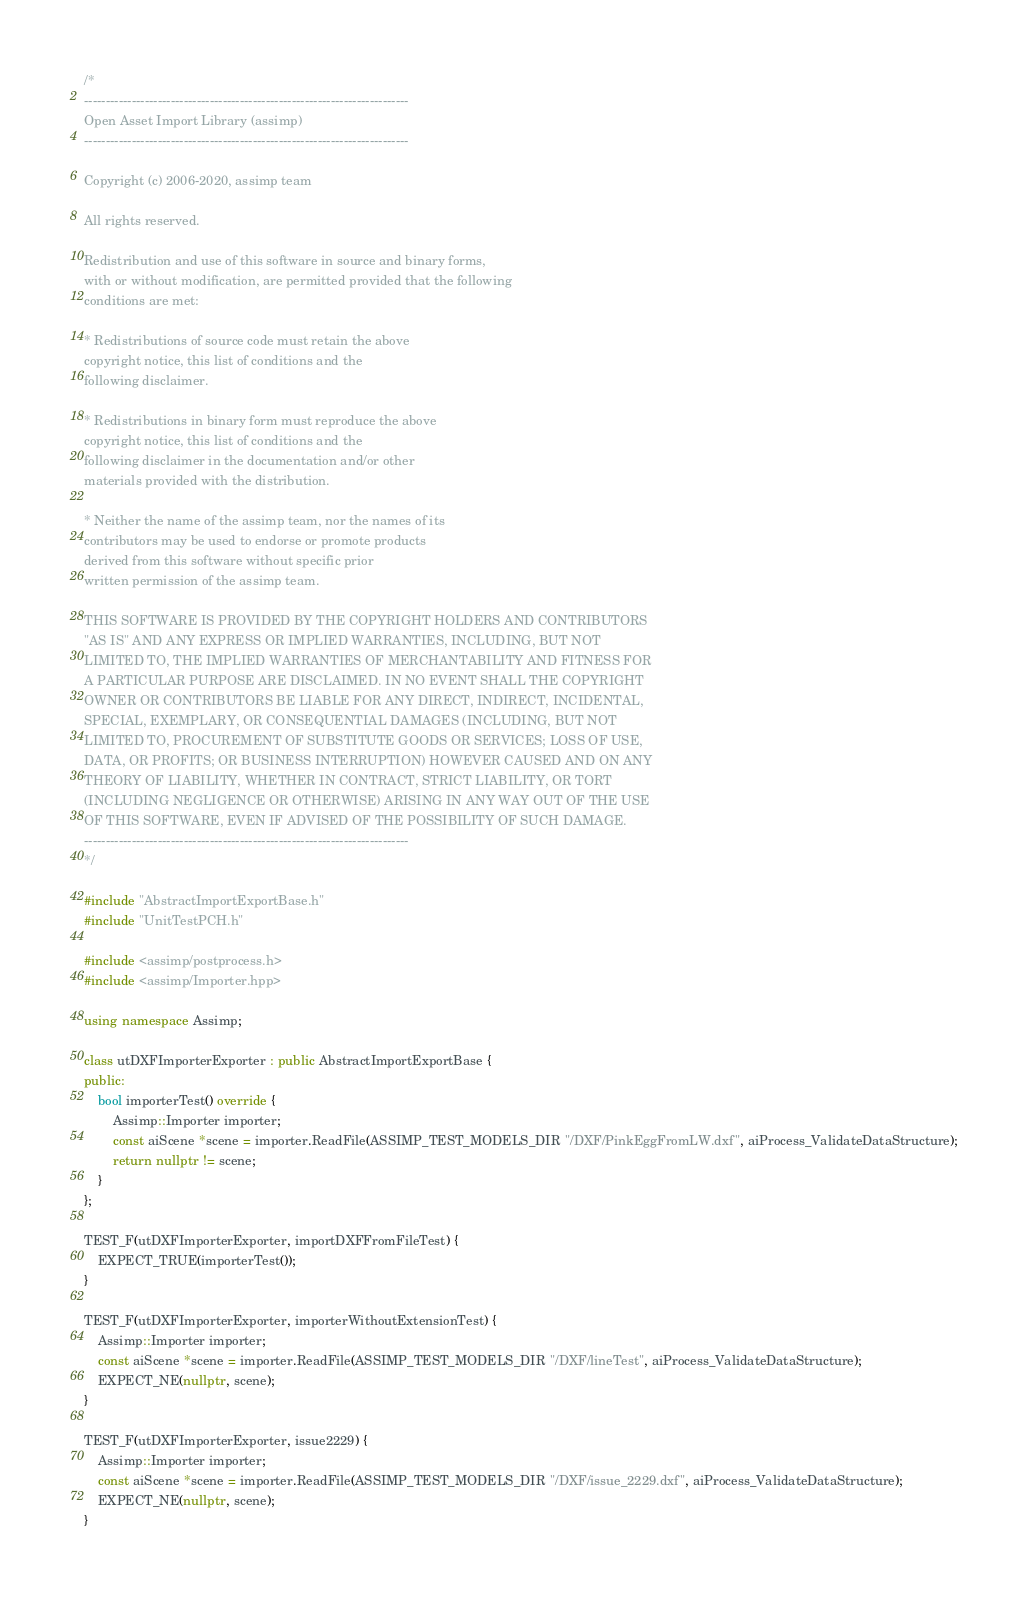<code> <loc_0><loc_0><loc_500><loc_500><_C++_>/*
---------------------------------------------------------------------------
Open Asset Import Library (assimp)
---------------------------------------------------------------------------

Copyright (c) 2006-2020, assimp team

All rights reserved.

Redistribution and use of this software in source and binary forms,
with or without modification, are permitted provided that the following
conditions are met:

* Redistributions of source code must retain the above
copyright notice, this list of conditions and the
following disclaimer.

* Redistributions in binary form must reproduce the above
copyright notice, this list of conditions and the
following disclaimer in the documentation and/or other
materials provided with the distribution.

* Neither the name of the assimp team, nor the names of its
contributors may be used to endorse or promote products
derived from this software without specific prior
written permission of the assimp team.

THIS SOFTWARE IS PROVIDED BY THE COPYRIGHT HOLDERS AND CONTRIBUTORS
"AS IS" AND ANY EXPRESS OR IMPLIED WARRANTIES, INCLUDING, BUT NOT
LIMITED TO, THE IMPLIED WARRANTIES OF MERCHANTABILITY AND FITNESS FOR
A PARTICULAR PURPOSE ARE DISCLAIMED. IN NO EVENT SHALL THE COPYRIGHT
OWNER OR CONTRIBUTORS BE LIABLE FOR ANY DIRECT, INDIRECT, INCIDENTAL,
SPECIAL, EXEMPLARY, OR CONSEQUENTIAL DAMAGES (INCLUDING, BUT NOT
LIMITED TO, PROCUREMENT OF SUBSTITUTE GOODS OR SERVICES; LOSS OF USE,
DATA, OR PROFITS; OR BUSINESS INTERRUPTION) HOWEVER CAUSED AND ON ANY
THEORY OF LIABILITY, WHETHER IN CONTRACT, STRICT LIABILITY, OR TORT
(INCLUDING NEGLIGENCE OR OTHERWISE) ARISING IN ANY WAY OUT OF THE USE
OF THIS SOFTWARE, EVEN IF ADVISED OF THE POSSIBILITY OF SUCH DAMAGE.
---------------------------------------------------------------------------
*/

#include "AbstractImportExportBase.h"
#include "UnitTestPCH.h"

#include <assimp/postprocess.h>
#include <assimp/Importer.hpp>

using namespace Assimp;

class utDXFImporterExporter : public AbstractImportExportBase {
public:
    bool importerTest() override {
        Assimp::Importer importer;
        const aiScene *scene = importer.ReadFile(ASSIMP_TEST_MODELS_DIR "/DXF/PinkEggFromLW.dxf", aiProcess_ValidateDataStructure);
        return nullptr != scene;
    }
};

TEST_F(utDXFImporterExporter, importDXFFromFileTest) {
    EXPECT_TRUE(importerTest());
}

TEST_F(utDXFImporterExporter, importerWithoutExtensionTest) {
    Assimp::Importer importer;
    const aiScene *scene = importer.ReadFile(ASSIMP_TEST_MODELS_DIR "/DXF/lineTest", aiProcess_ValidateDataStructure);
    EXPECT_NE(nullptr, scene);
}

TEST_F(utDXFImporterExporter, issue2229) {
    Assimp::Importer importer;
    const aiScene *scene = importer.ReadFile(ASSIMP_TEST_MODELS_DIR "/DXF/issue_2229.dxf", aiProcess_ValidateDataStructure);
    EXPECT_NE(nullptr, scene);
}
</code> 